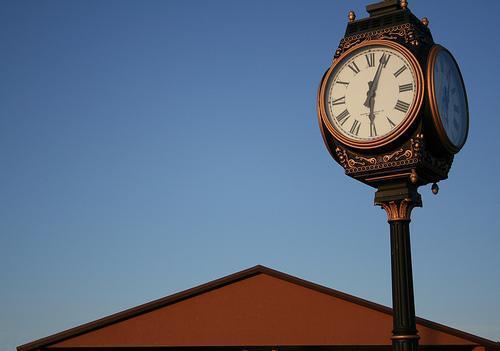How many clocks are in the photo?
Give a very brief answer. 1. 